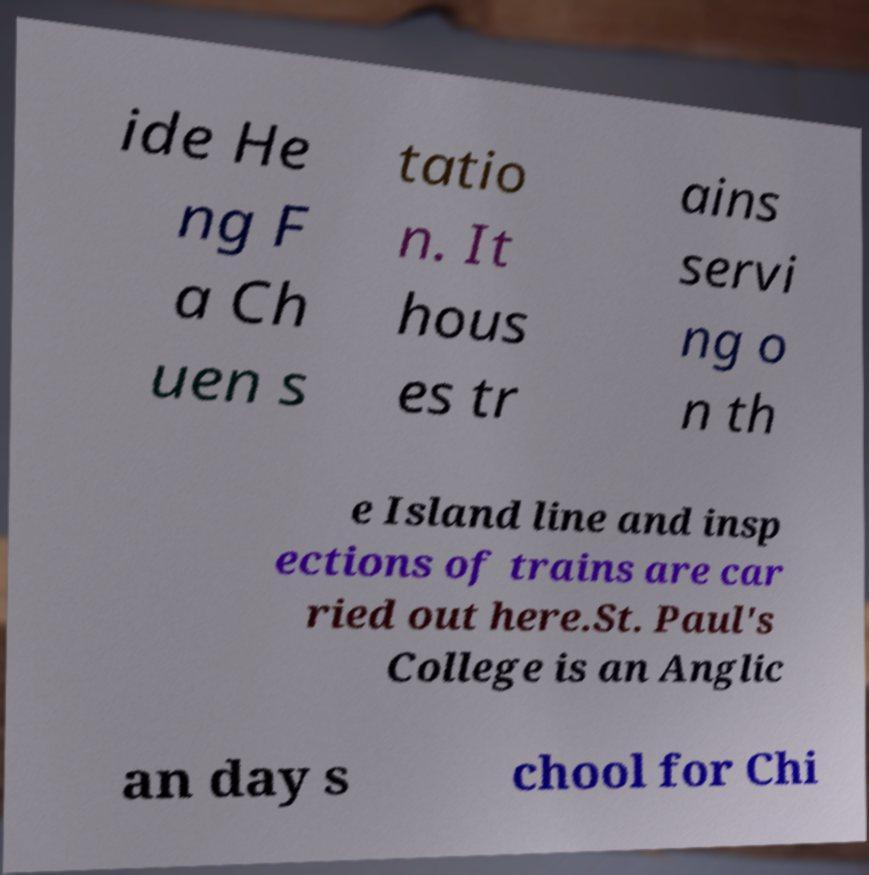Please read and relay the text visible in this image. What does it say? ide He ng F a Ch uen s tatio n. It hous es tr ains servi ng o n th e Island line and insp ections of trains are car ried out here.St. Paul's College is an Anglic an day s chool for Chi 